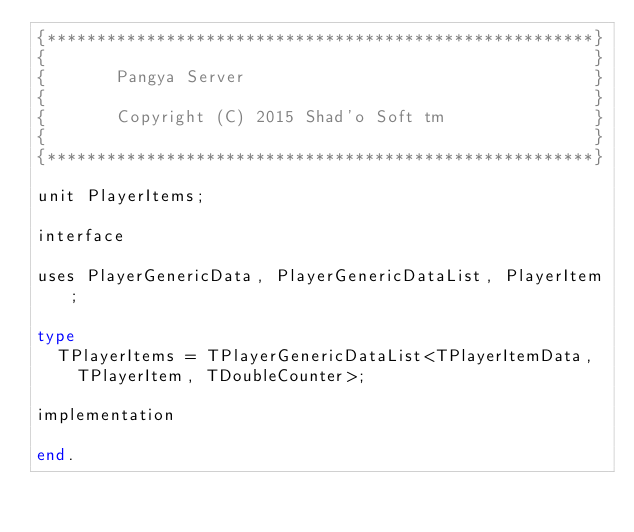<code> <loc_0><loc_0><loc_500><loc_500><_Pascal_>{*******************************************************}
{                                                       }
{       Pangya Server                                   }
{                                                       }
{       Copyright (C) 2015 Shad'o Soft tm               }
{                                                       }
{*******************************************************}

unit PlayerItems;

interface

uses PlayerGenericData, PlayerGenericDataList, PlayerItem;

type
  TPlayerItems = TPlayerGenericDataList<TPlayerItemData,
    TPlayerItem, TDoubleCounter>;

implementation

end.
</code> 